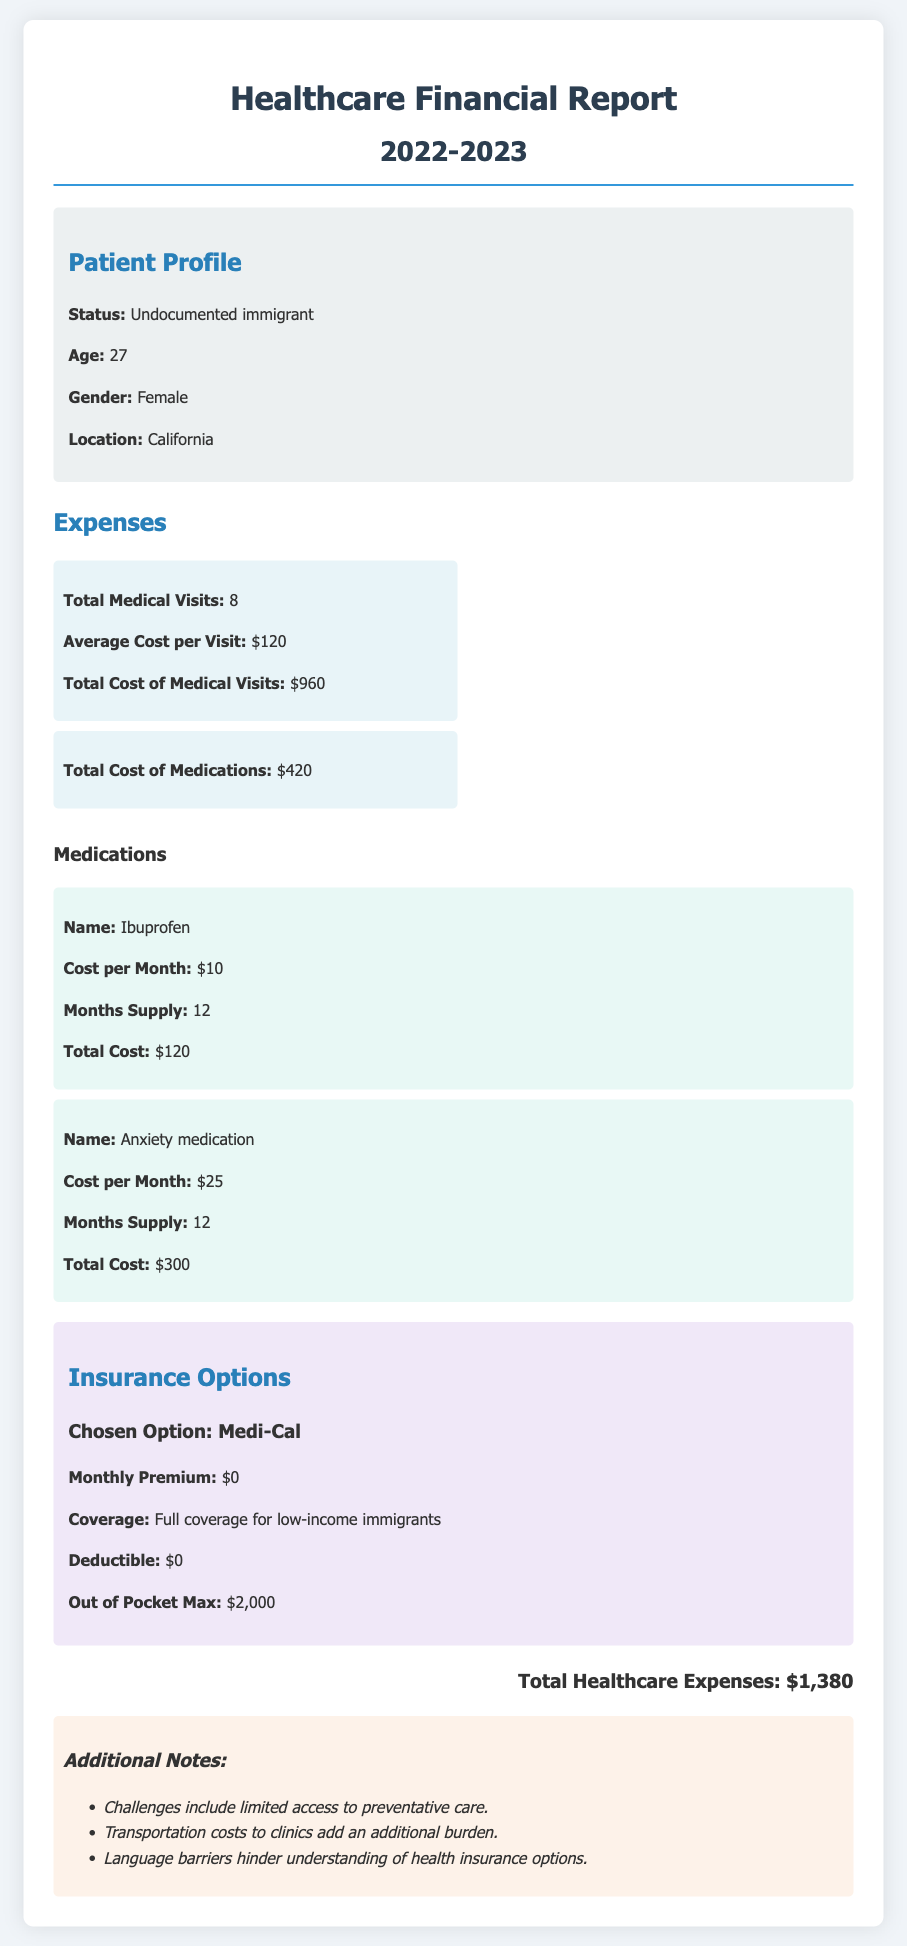What is the total number of medical visits? The total number of medical visits is specified as 8 in the expenses section of the report.
Answer: 8 What is the total cost of medical visits? The total cost of medical visits is calculated as $960, as stated in the expenses section.
Answer: $960 What is the monthly premium for the chosen insurance option? The report indicates that the monthly premium for the chosen insurance option (Medi-Cal) is $0.
Answer: $0 What is the total cost of medications? The total cost of medications listed in the document amounts to $420.
Answer: $420 What was the cost of the anxiety medication? The report details the anxiety medication cost as $25 per month for 12 months, resulting in a total of $300.
Answer: $300 What is the out-of-pocket maximum for the insurance option? The out-of-pocket maximum for the insurance option (Medi-Cal) is stated as $2,000.
Answer: $2,000 What are some challenges mentioned in the report? The report highlights challenges that include limited access to preventative care, transportation costs, and language barriers.
Answer: Limited access to preventative care, transportation costs, and language barriers What is the total healthcare expense for the year? The document summarizes the total healthcare expenses as $1,380 at the end of the report.
Answer: $1,380 What is the cost per month for Ibuprofen? The report states that the cost per month for Ibuprofen is $10.
Answer: $10 